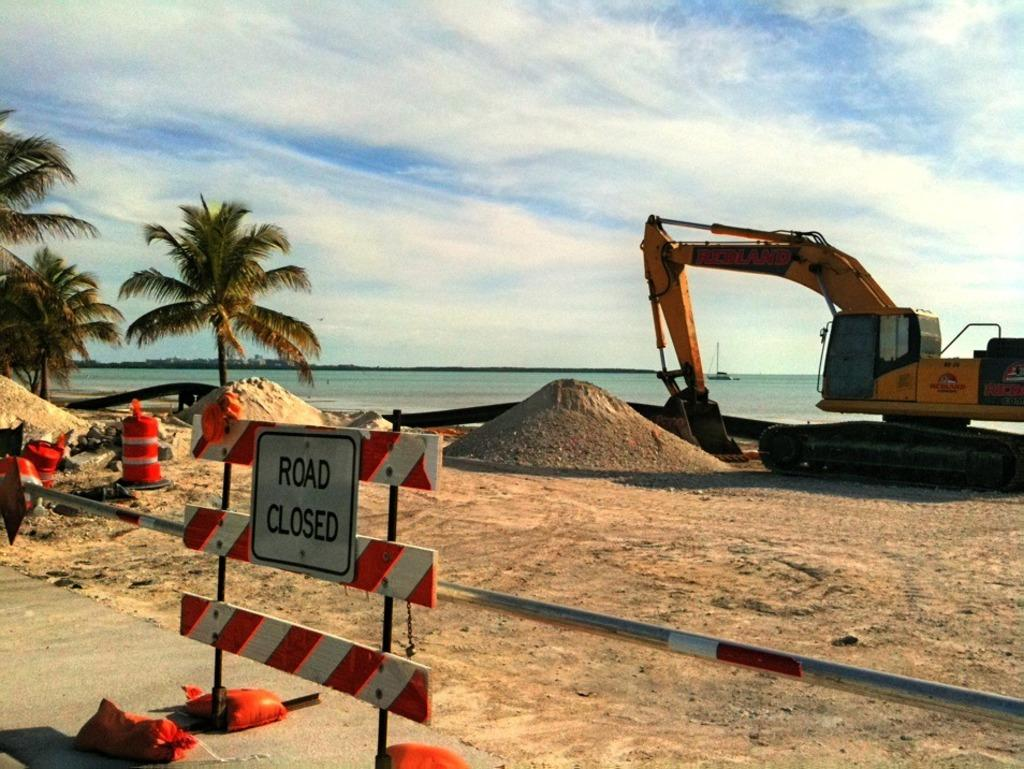What is the main object in the image? There is a name board in the image. What else can be seen in the image besides the name board? There is a pole, sand, trees, an excavator on the ground, a boat on the water, and objects in the image. What is the background of the image? The sky is visible in the background of the image, with clouds present. Can you describe the landscape in the image? The image features sand, trees, and a body of water with a boat on it. What type of street is visible in the image? There is no street present in the image. 